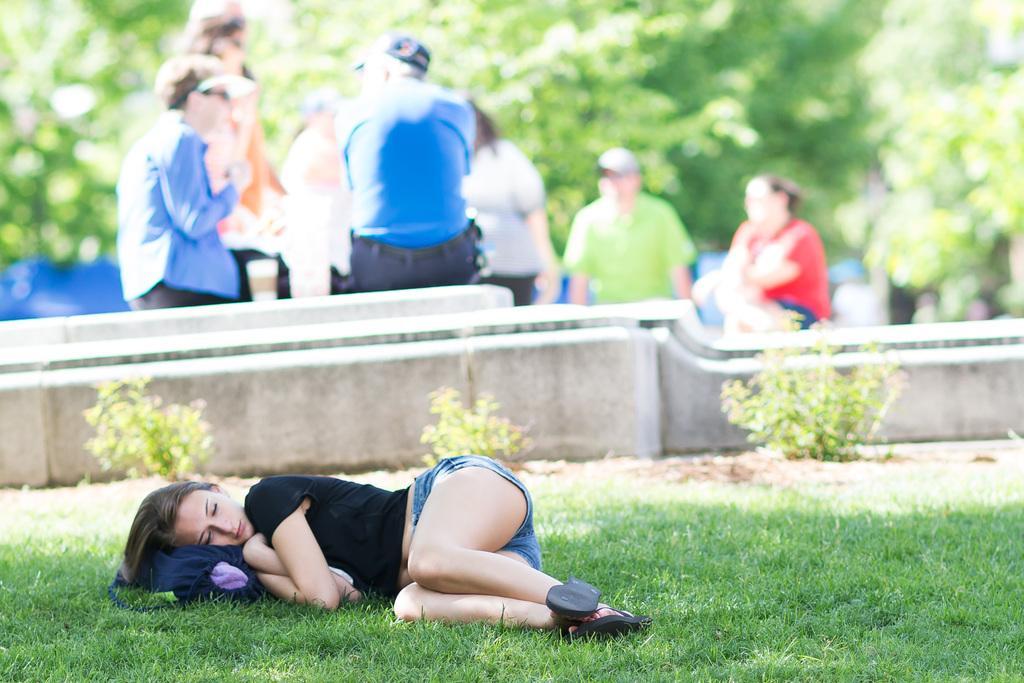Can you describe this image briefly? In the foreground of the image there is a lady sleeping on the grass. In the background of the image there are people. There are trees. In the center of the image there are plants. 